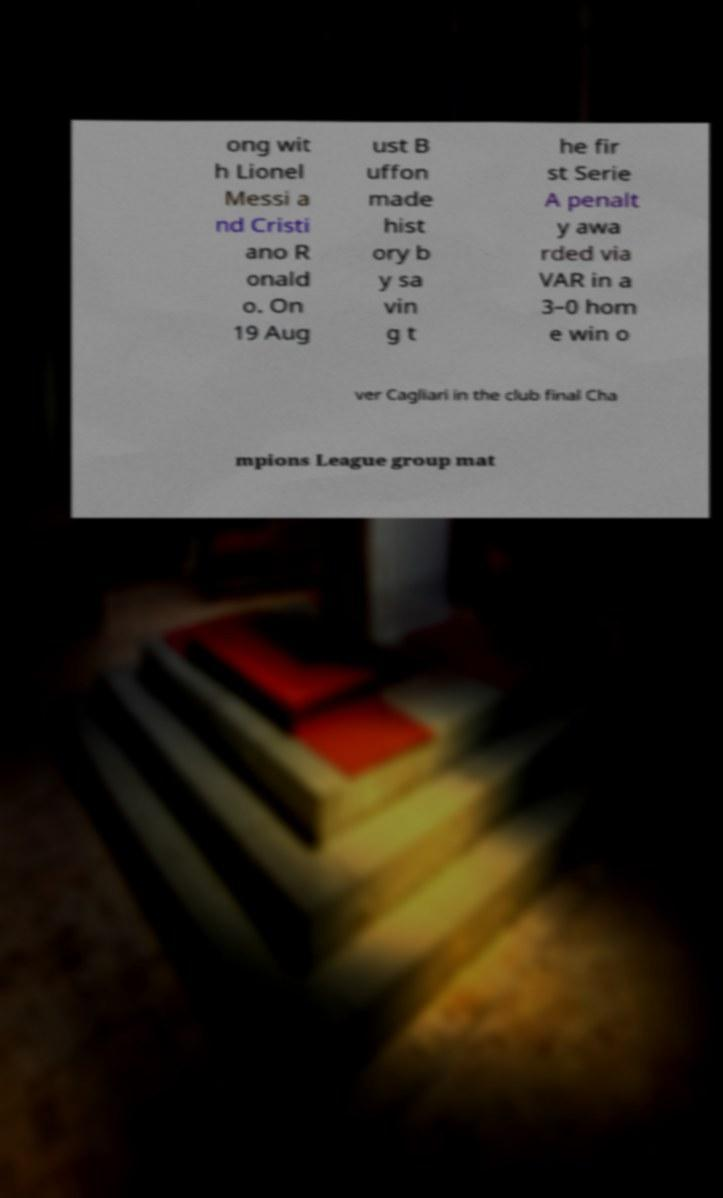Can you accurately transcribe the text from the provided image for me? ong wit h Lionel Messi a nd Cristi ano R onald o. On 19 Aug ust B uffon made hist ory b y sa vin g t he fir st Serie A penalt y awa rded via VAR in a 3–0 hom e win o ver Cagliari in the club final Cha mpions League group mat 